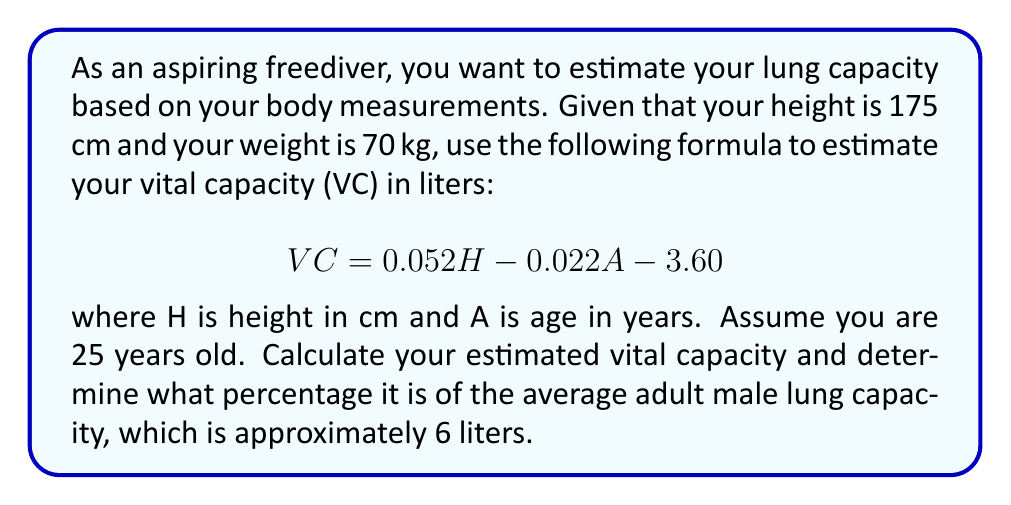Can you answer this question? To solve this problem, we'll follow these steps:

1. Calculate the vital capacity (VC) using the given formula:
   $$VC = 0.052H - 0.022A - 3.60$$
   
   Substituting the values:
   H = 175 cm
   A = 25 years
   
   $$VC = 0.052(175) - 0.022(25) - 3.60$$
   $$VC = 9.1 - 0.55 - 3.60$$
   $$VC = 4.95 \text{ liters}$$

2. Calculate the percentage of the estimated vital capacity compared to the average adult male lung capacity:
   
   Average adult male lung capacity = 6 liters
   
   Percentage = $\frac{\text{Estimated VC}}{\text{Average capacity}} \times 100\%$
   
   $$\text{Percentage} = \frac{4.95}{6} \times 100\% = 82.5\%$$

Therefore, your estimated vital capacity is 4.95 liters, which is 82.5% of the average adult male lung capacity.
Answer: 4.95 liters, 82.5% 